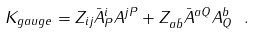<formula> <loc_0><loc_0><loc_500><loc_500>K _ { g a u g e } = Z _ { i j } \bar { A } ^ { i } _ { P } A ^ { j P } + Z _ { a \bar { b } } \bar { A } ^ { a Q } A ^ { b } _ { Q } \ .</formula> 